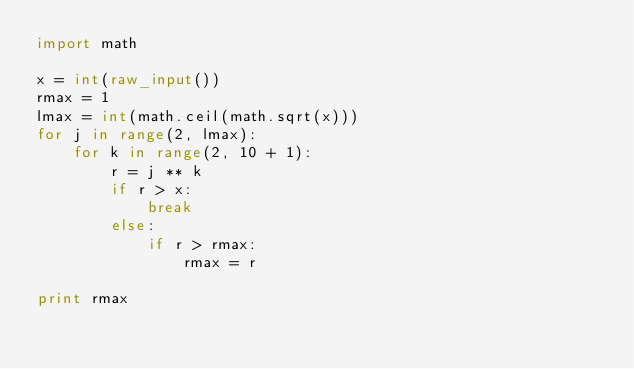<code> <loc_0><loc_0><loc_500><loc_500><_Python_>import math

x = int(raw_input())
rmax = 1
lmax = int(math.ceil(math.sqrt(x)))
for j in range(2, lmax):
    for k in range(2, 10 + 1):
        r = j ** k
        if r > x:
            break
        else:
            if r > rmax:
                rmax = r

print rmax</code> 